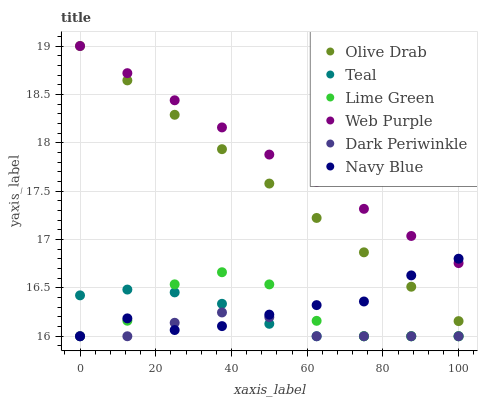Does Dark Periwinkle have the minimum area under the curve?
Answer yes or no. Yes. Does Web Purple have the maximum area under the curve?
Answer yes or no. Yes. Does Teal have the minimum area under the curve?
Answer yes or no. No. Does Teal have the maximum area under the curve?
Answer yes or no. No. Is Web Purple the smoothest?
Answer yes or no. Yes. Is Lime Green the roughest?
Answer yes or no. Yes. Is Teal the smoothest?
Answer yes or no. No. Is Teal the roughest?
Answer yes or no. No. Does Navy Blue have the lowest value?
Answer yes or no. Yes. Does Web Purple have the lowest value?
Answer yes or no. No. Does Olive Drab have the highest value?
Answer yes or no. Yes. Does Teal have the highest value?
Answer yes or no. No. Is Dark Periwinkle less than Web Purple?
Answer yes or no. Yes. Is Olive Drab greater than Lime Green?
Answer yes or no. Yes. Does Teal intersect Navy Blue?
Answer yes or no. Yes. Is Teal less than Navy Blue?
Answer yes or no. No. Is Teal greater than Navy Blue?
Answer yes or no. No. Does Dark Periwinkle intersect Web Purple?
Answer yes or no. No. 